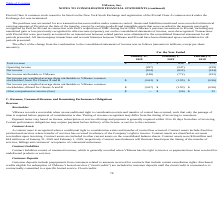According to Vmware's financial document, What was the total revenue in 2020? According to the financial document, 777 (in millions). The relevant text states: "Total revenue $ 777 $ 639 $ 474..." Also, What was the net income in 2018? According to the financial document, (234) (in millions). The relevant text states: "Net income (204) (832) (234)..." Also, Which years does the table provide information for the effect of the change from the combination to the consolidated statements of income? The document contains multiple relevant values: 2020, 2019, 2018. From the document: "2020 2019 2018 2020 2019 2018 2020 2019 2018..." Also, can you calculate: What was the change in total revenue between 2018 and 2019? Based on the calculation: 639-474, the result is 165 (in millions). This is based on the information: "Total revenue $ 777 $ 639 $ 474 Total revenue $ 777 $ 639 $ 474..." The key data points involved are: 474, 639. Also, How many years did total revenue exceed $500 million? Counting the relevant items in the document: 2020, 2019, I find 2 instances. The key data points involved are: 2019, 2020. Also, can you calculate: What was the percentage change in net income between 2019 and 2020? To answer this question, I need to perform calculations using the financial data. The calculation is: (-204-(-832))/-832, which equals -75.48 (percentage). This is based on the information: "Net income (204) (832) (234) Net income (204) (832) (234)..." The key data points involved are: 204, 832. 